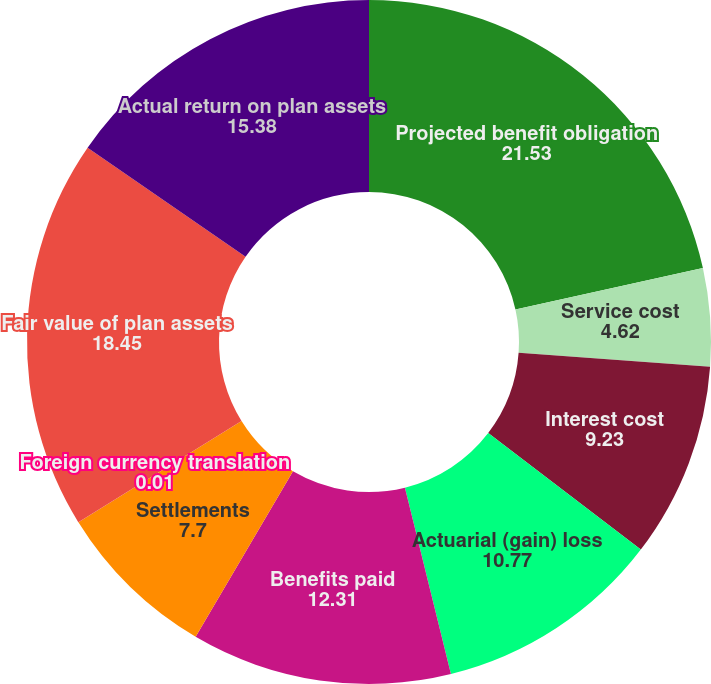Convert chart to OTSL. <chart><loc_0><loc_0><loc_500><loc_500><pie_chart><fcel>Projected benefit obligation<fcel>Service cost<fcel>Interest cost<fcel>Actuarial (gain) loss<fcel>Benefits paid<fcel>Settlements<fcel>Foreign currency translation<fcel>Fair value of plan assets<fcel>Actual return on plan assets<nl><fcel>21.53%<fcel>4.62%<fcel>9.23%<fcel>10.77%<fcel>12.31%<fcel>7.7%<fcel>0.01%<fcel>18.45%<fcel>15.38%<nl></chart> 